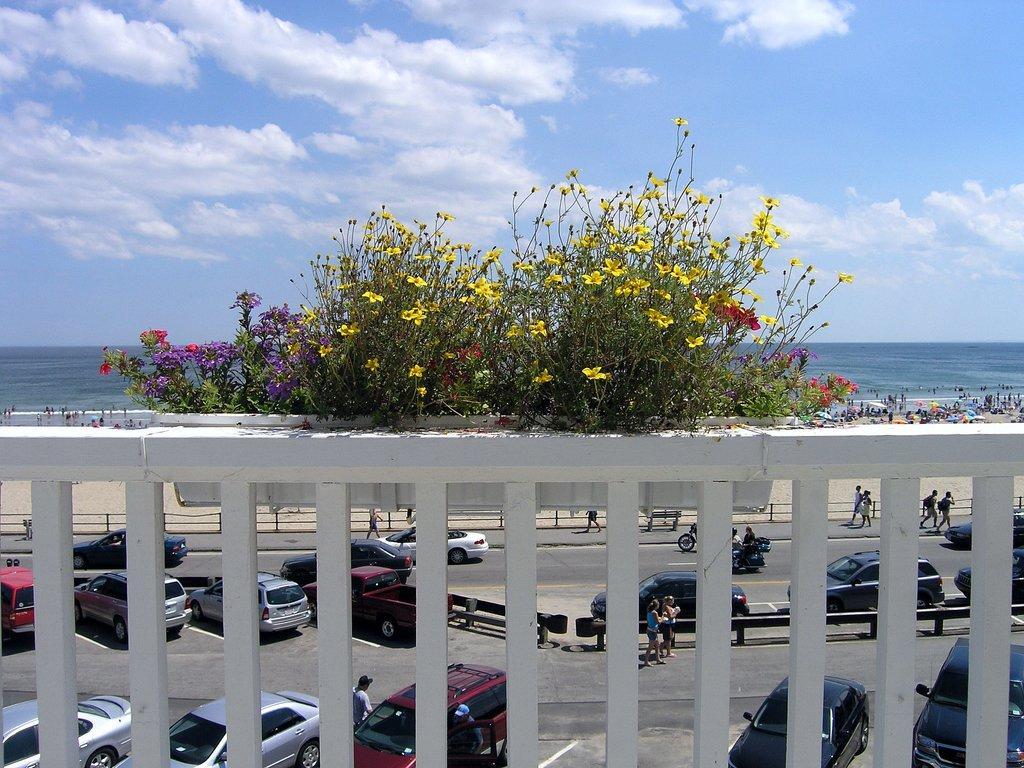Can you describe this image briefly? In the image there is a railing. On the railing there are plants with yellow, violet and red flowers. Behind the railing there are few cars and few people are on the road. And also there is a footpath few people and railing to it. Behind the plants there are many people on the seashore and also there is water. At the top of the image there is a sky with clouds. 